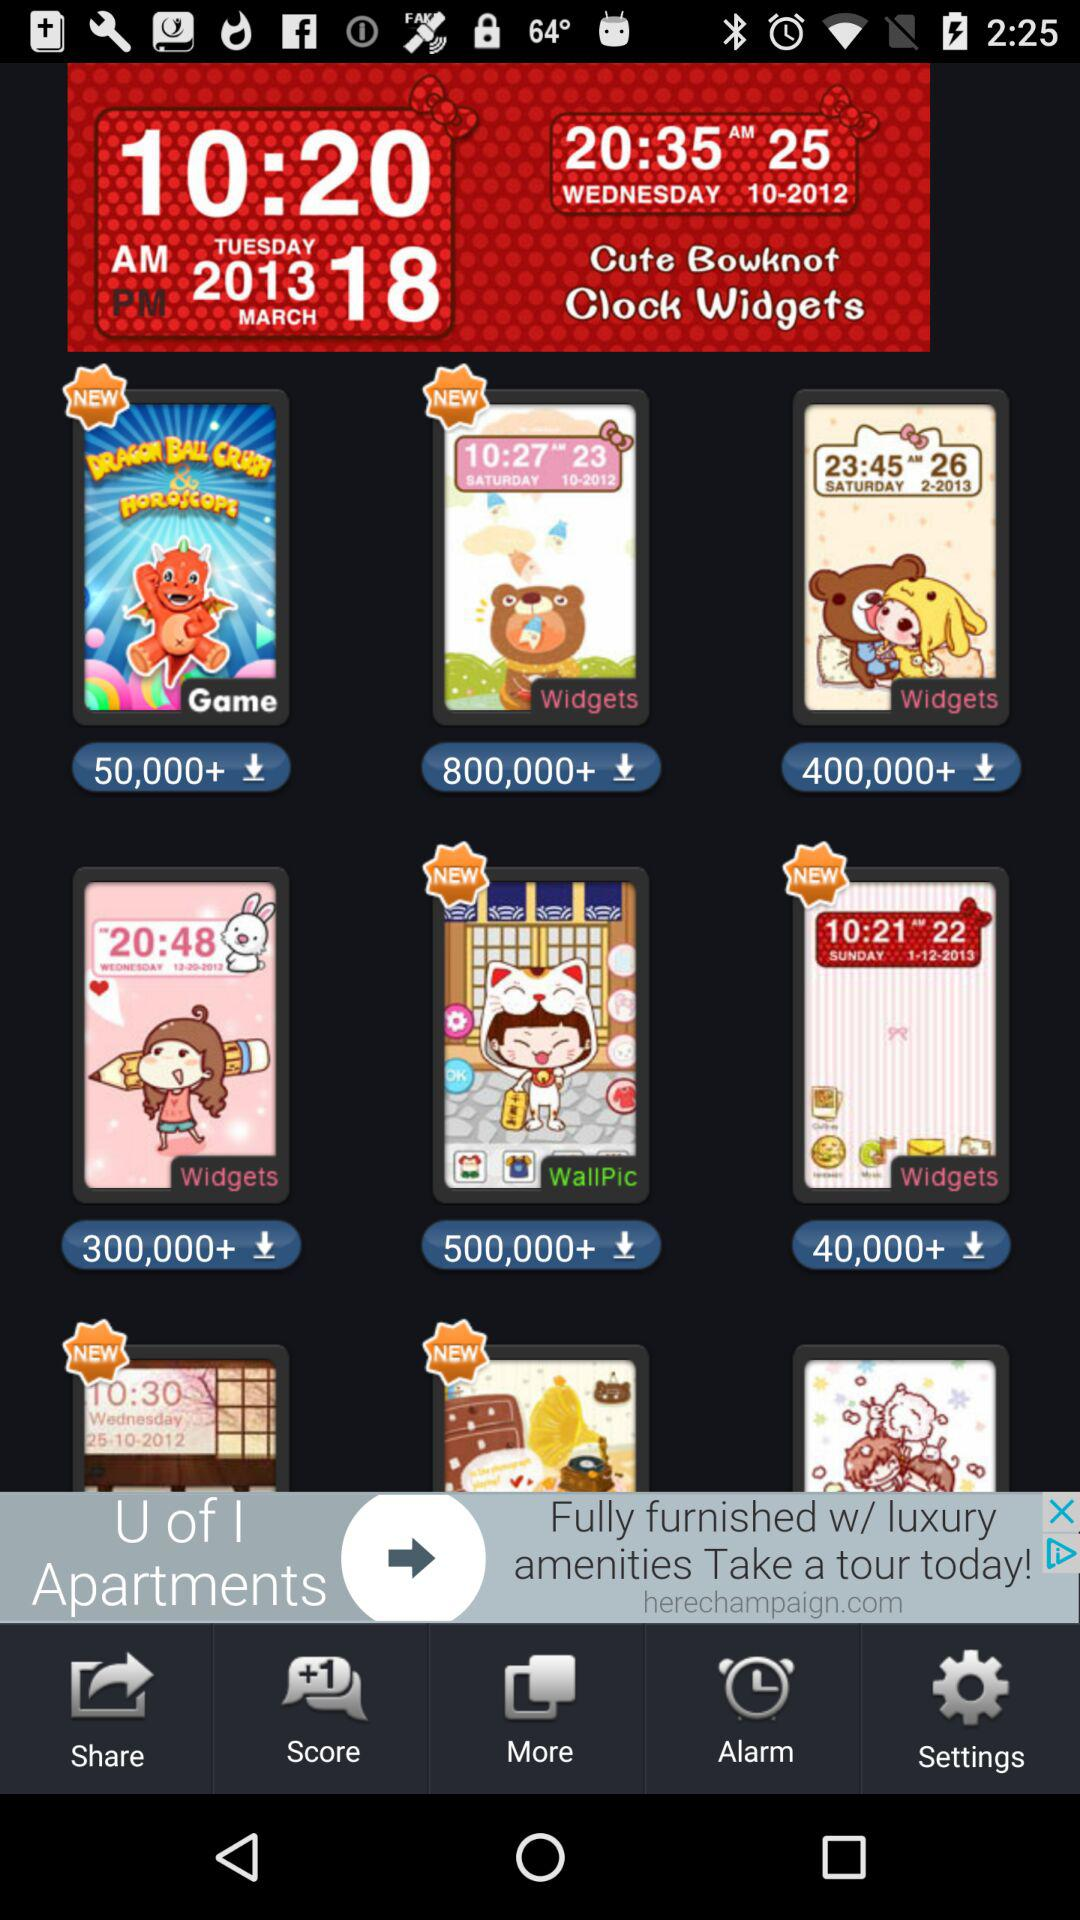What is the given date and time?
When the provided information is insufficient, respond with <no answer>. <no answer> 